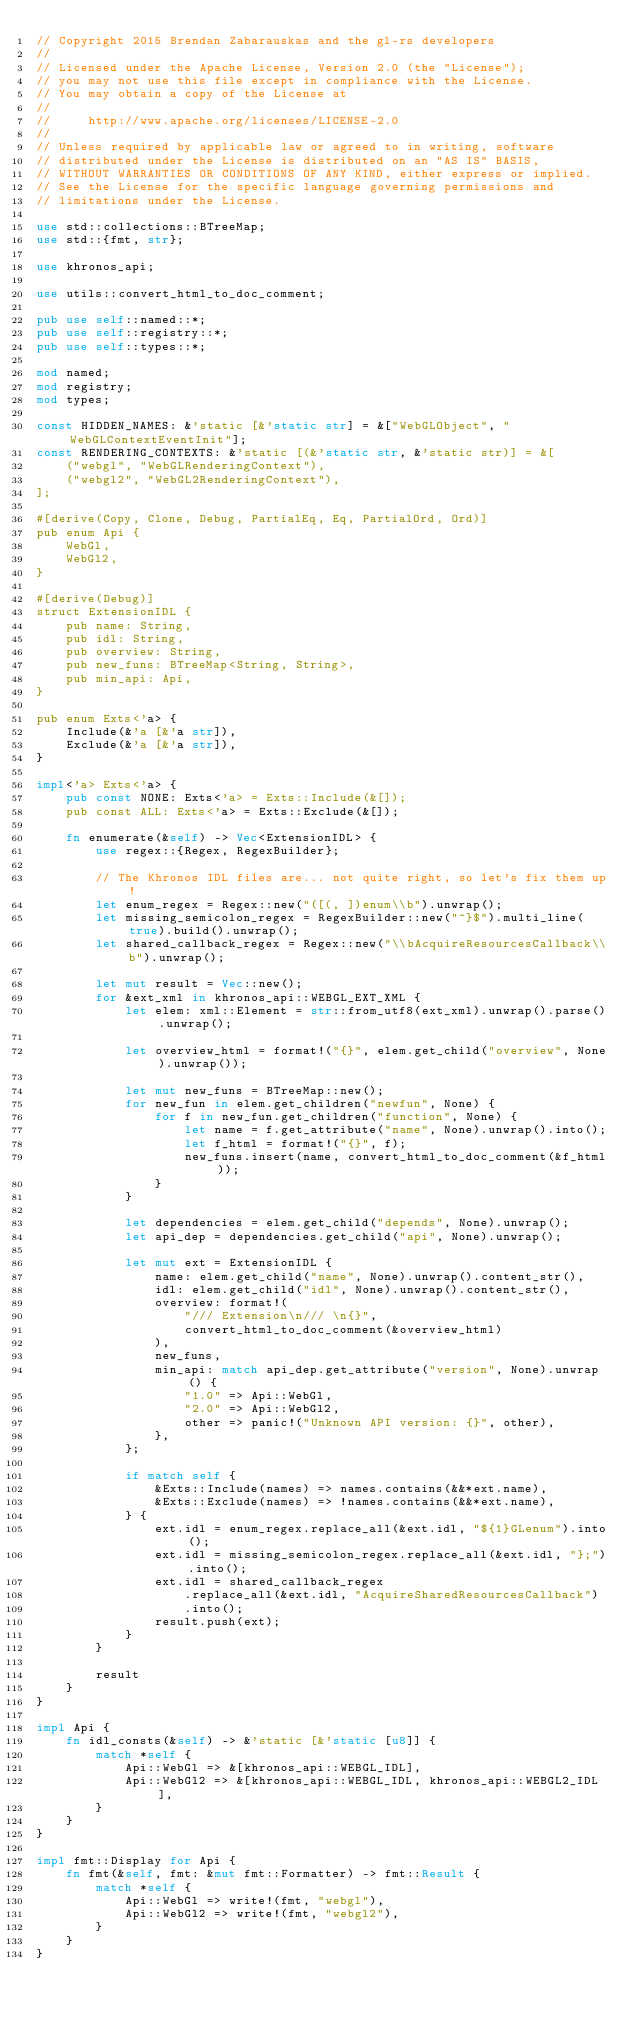<code> <loc_0><loc_0><loc_500><loc_500><_Rust_>// Copyright 2015 Brendan Zabarauskas and the gl-rs developers
//
// Licensed under the Apache License, Version 2.0 (the "License");
// you may not use this file except in compliance with the License.
// You may obtain a copy of the License at
//
//     http://www.apache.org/licenses/LICENSE-2.0
//
// Unless required by applicable law or agreed to in writing, software
// distributed under the License is distributed on an "AS IS" BASIS,
// WITHOUT WARRANTIES OR CONDITIONS OF ANY KIND, either express or implied.
// See the License for the specific language governing permissions and
// limitations under the License.

use std::collections::BTreeMap;
use std::{fmt, str};

use khronos_api;

use utils::convert_html_to_doc_comment;

pub use self::named::*;
pub use self::registry::*;
pub use self::types::*;

mod named;
mod registry;
mod types;

const HIDDEN_NAMES: &'static [&'static str] = &["WebGLObject", "WebGLContextEventInit"];
const RENDERING_CONTEXTS: &'static [(&'static str, &'static str)] = &[
    ("webgl", "WebGLRenderingContext"),
    ("webgl2", "WebGL2RenderingContext"),
];

#[derive(Copy, Clone, Debug, PartialEq, Eq, PartialOrd, Ord)]
pub enum Api {
    WebGl,
    WebGl2,
}

#[derive(Debug)]
struct ExtensionIDL {
    pub name: String,
    pub idl: String,
    pub overview: String,
    pub new_funs: BTreeMap<String, String>,
    pub min_api: Api,
}

pub enum Exts<'a> {
    Include(&'a [&'a str]),
    Exclude(&'a [&'a str]),
}

impl<'a> Exts<'a> {
    pub const NONE: Exts<'a> = Exts::Include(&[]);
    pub const ALL: Exts<'a> = Exts::Exclude(&[]);

    fn enumerate(&self) -> Vec<ExtensionIDL> {
        use regex::{Regex, RegexBuilder};

        // The Khronos IDL files are... not quite right, so let's fix them up!
        let enum_regex = Regex::new("([(, ])enum\\b").unwrap();
        let missing_semicolon_regex = RegexBuilder::new("^}$").multi_line(true).build().unwrap();
        let shared_callback_regex = Regex::new("\\bAcquireResourcesCallback\\b").unwrap();

        let mut result = Vec::new();
        for &ext_xml in khronos_api::WEBGL_EXT_XML {
            let elem: xml::Element = str::from_utf8(ext_xml).unwrap().parse().unwrap();

            let overview_html = format!("{}", elem.get_child("overview", None).unwrap());

            let mut new_funs = BTreeMap::new();
            for new_fun in elem.get_children("newfun", None) {
                for f in new_fun.get_children("function", None) {
                    let name = f.get_attribute("name", None).unwrap().into();
                    let f_html = format!("{}", f);
                    new_funs.insert(name, convert_html_to_doc_comment(&f_html));
                }
            }

            let dependencies = elem.get_child("depends", None).unwrap();
            let api_dep = dependencies.get_child("api", None).unwrap();

            let mut ext = ExtensionIDL {
                name: elem.get_child("name", None).unwrap().content_str(),
                idl: elem.get_child("idl", None).unwrap().content_str(),
                overview: format!(
                    "/// Extension\n/// \n{}",
                    convert_html_to_doc_comment(&overview_html)
                ),
                new_funs,
                min_api: match api_dep.get_attribute("version", None).unwrap() {
                    "1.0" => Api::WebGl,
                    "2.0" => Api::WebGl2,
                    other => panic!("Unknown API version: {}", other),
                },
            };

            if match self {
                &Exts::Include(names) => names.contains(&&*ext.name),
                &Exts::Exclude(names) => !names.contains(&&*ext.name),
            } {
                ext.idl = enum_regex.replace_all(&ext.idl, "${1}GLenum").into();
                ext.idl = missing_semicolon_regex.replace_all(&ext.idl, "};").into();
                ext.idl = shared_callback_regex
                    .replace_all(&ext.idl, "AcquireSharedResourcesCallback")
                    .into();
                result.push(ext);
            }
        }

        result
    }
}

impl Api {
    fn idl_consts(&self) -> &'static [&'static [u8]] {
        match *self {
            Api::WebGl => &[khronos_api::WEBGL_IDL],
            Api::WebGl2 => &[khronos_api::WEBGL_IDL, khronos_api::WEBGL2_IDL],
        }
    }
}

impl fmt::Display for Api {
    fn fmt(&self, fmt: &mut fmt::Formatter) -> fmt::Result {
        match *self {
            Api::WebGl => write!(fmt, "webgl"),
            Api::WebGl2 => write!(fmt, "webgl2"),
        }
    }
}
</code> 